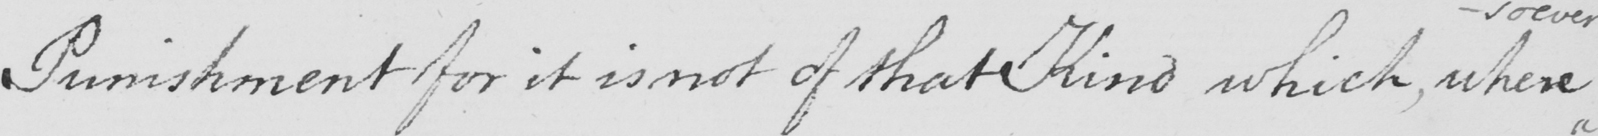Transcribe the text shown in this historical manuscript line. Punishment for it is not of that Kind which , where 